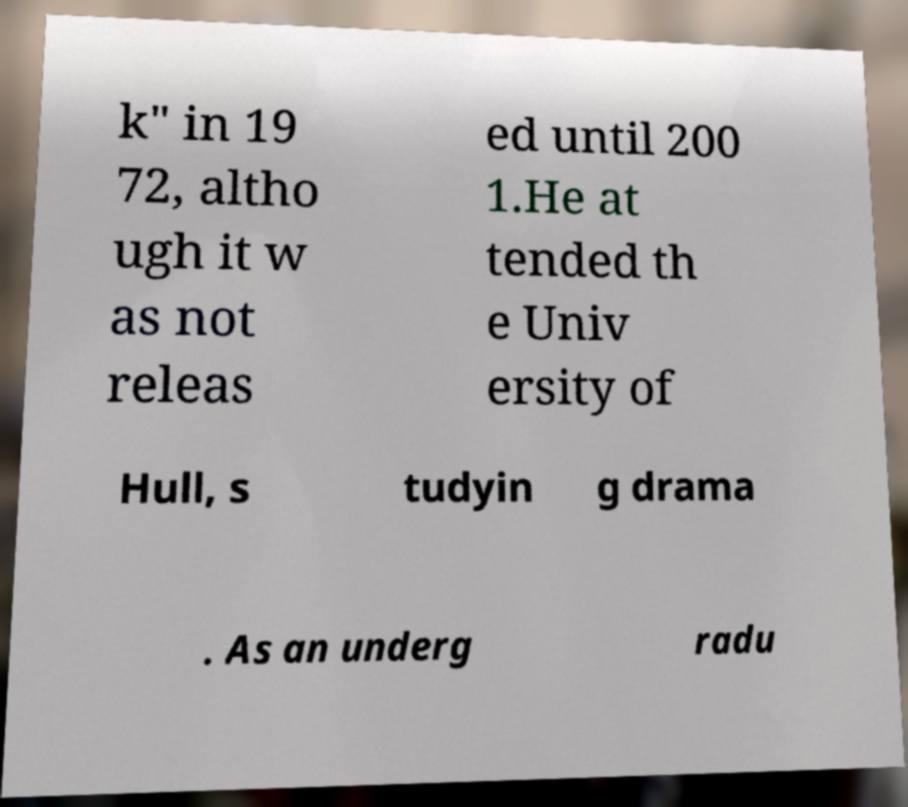I need the written content from this picture converted into text. Can you do that? k" in 19 72, altho ugh it w as not releas ed until 200 1.He at tended th e Univ ersity of Hull, s tudyin g drama . As an underg radu 